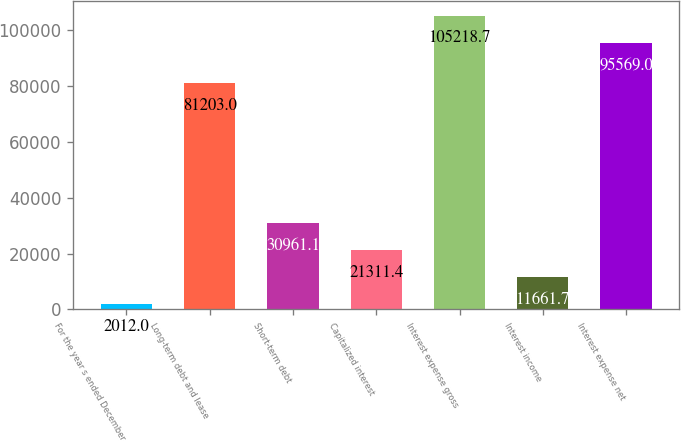<chart> <loc_0><loc_0><loc_500><loc_500><bar_chart><fcel>For the year s ended December<fcel>Long-term debt and lease<fcel>Short-term debt<fcel>Capitalized interest<fcel>Interest expense gross<fcel>Interest income<fcel>Interest expense net<nl><fcel>2012<fcel>81203<fcel>30961.1<fcel>21311.4<fcel>105219<fcel>11661.7<fcel>95569<nl></chart> 